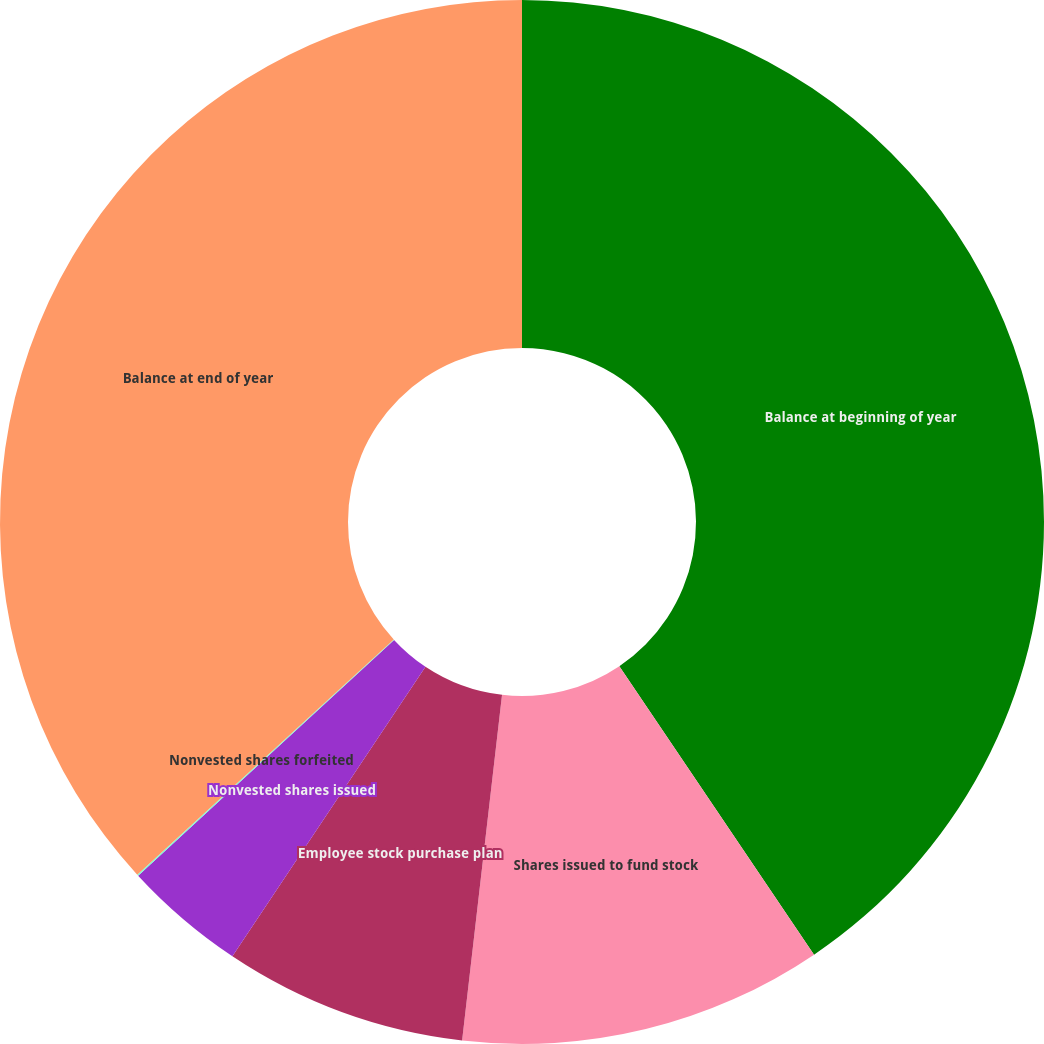Convert chart. <chart><loc_0><loc_0><loc_500><loc_500><pie_chart><fcel>Balance at beginning of year<fcel>Shares issued to fund stock<fcel>Employee stock purchase plan<fcel>Nonvested shares issued<fcel>Nonvested shares forfeited<fcel>Balance at end of year<nl><fcel>40.55%<fcel>11.28%<fcel>7.53%<fcel>3.79%<fcel>0.04%<fcel>36.81%<nl></chart> 